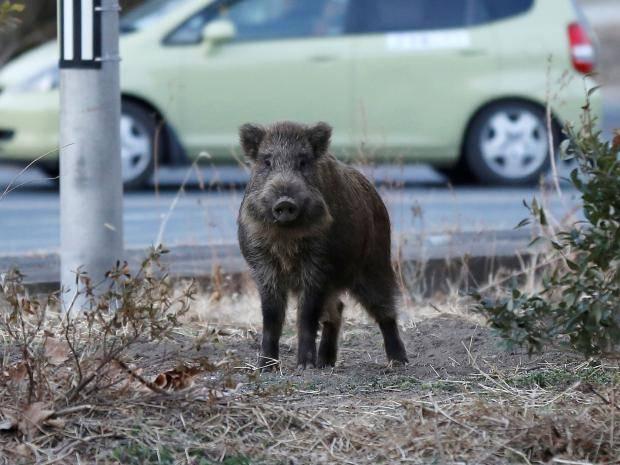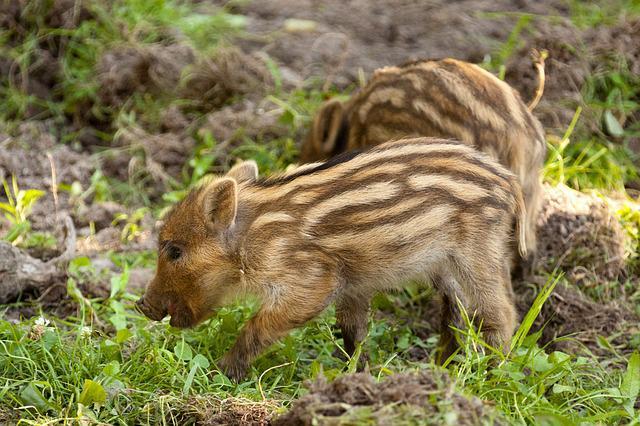The first image is the image on the left, the second image is the image on the right. Assess this claim about the two images: "In one image, a boar is standing in snow.". Correct or not? Answer yes or no. No. The first image is the image on the left, the second image is the image on the right. Analyze the images presented: Is the assertion "One image contains only baby piglets with distinctive brown and beige striped fur, standing on ground with bright green grass." valid? Answer yes or no. Yes. 